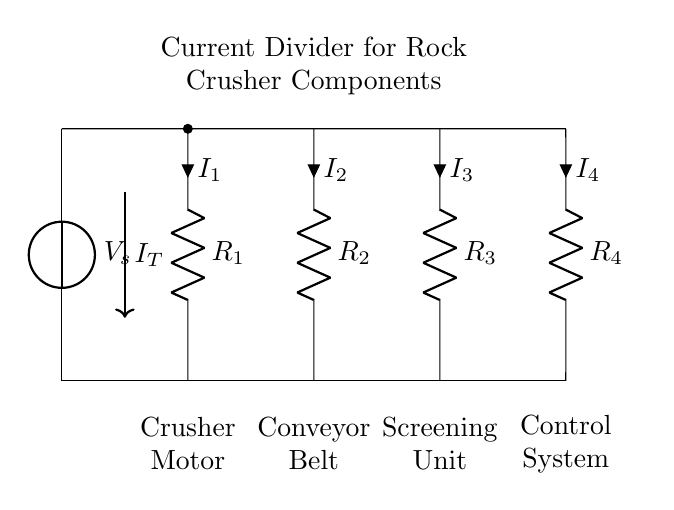What is the source voltage in this circuit? The source voltage is labeled as V_s, which is the voltage attached to the circuit to power the different components.
Answer: V_s Which component has the highest resistance? To determine resistance values, one would look for the resistor with the largest value. However, since specific values are not provided in the diagram, a general assumption can be made based on typical applications. In a real scenario, resistances would be specified; here, we cannot definitively answer without more data.
Answer: Cannot determine How many components are in the current divider? There are four resistors labeled R_1, R_2, R_3, and R_4, making up the current divider circuit. Counting these gives a total of four components.
Answer: Four What is the current through the conveyor belt? The current through the conveyor belt is denoted as I_2, which represents the flow of current specifically through the resistor associated with the conveyor belt component in the circuit.
Answer: I_2 Which component is associated with the current labeled I_4? The component associated with I_4 is the control system, as indicated by the label adjacent to the corresponding resistor in the circuit diagram.
Answer: Control system Explain how current division occurs in this circuit. Current division occurs when the total current entering the circuit splits into multiple paths, with the amount of current through each path being inversely proportional to the resistance values of each branch. The lower the resistance, the higher the current flowing through that branch according to the current division rule I_x = I_T * (R_total / R_x). This mechanism optimizes energy use across the crusher components.
Answer: Current division rule 